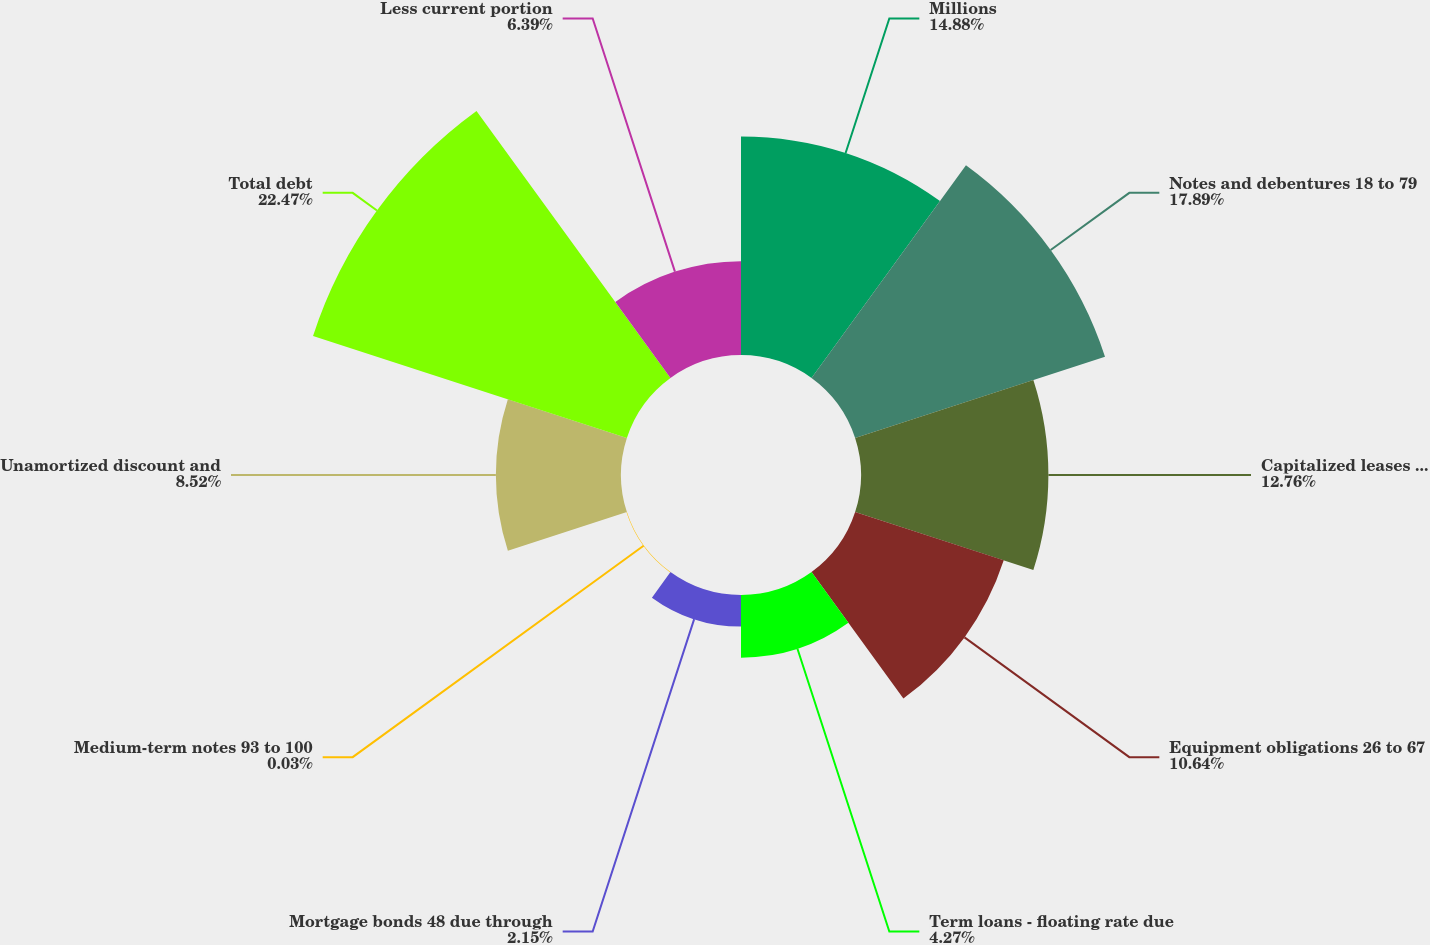<chart> <loc_0><loc_0><loc_500><loc_500><pie_chart><fcel>Millions<fcel>Notes and debentures 18 to 79<fcel>Capitalized leases 31 to 84<fcel>Equipment obligations 26 to 67<fcel>Term loans - floating rate due<fcel>Mortgage bonds 48 due through<fcel>Medium-term notes 93 to 100<fcel>Unamortized discount and<fcel>Total debt<fcel>Less current portion<nl><fcel>14.88%<fcel>17.89%<fcel>12.76%<fcel>10.64%<fcel>4.27%<fcel>2.15%<fcel>0.03%<fcel>8.52%<fcel>22.47%<fcel>6.39%<nl></chart> 